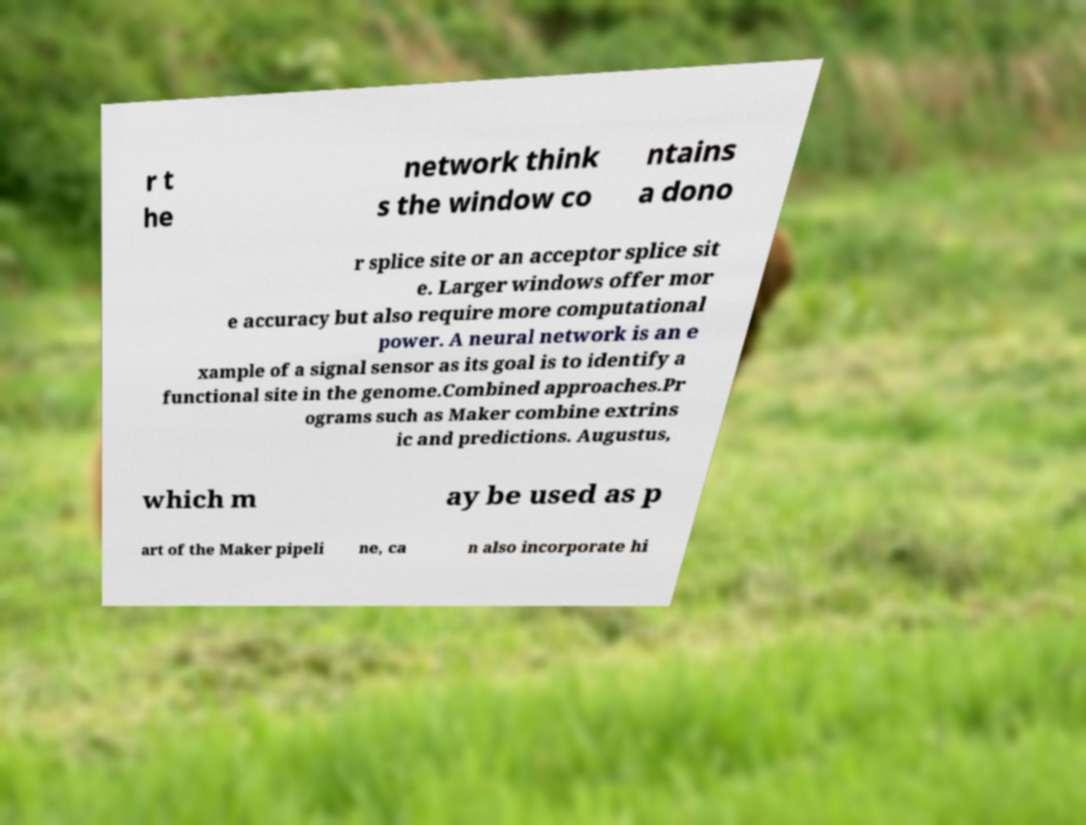Please identify and transcribe the text found in this image. r t he network think s the window co ntains a dono r splice site or an acceptor splice sit e. Larger windows offer mor e accuracy but also require more computational power. A neural network is an e xample of a signal sensor as its goal is to identify a functional site in the genome.Combined approaches.Pr ograms such as Maker combine extrins ic and predictions. Augustus, which m ay be used as p art of the Maker pipeli ne, ca n also incorporate hi 